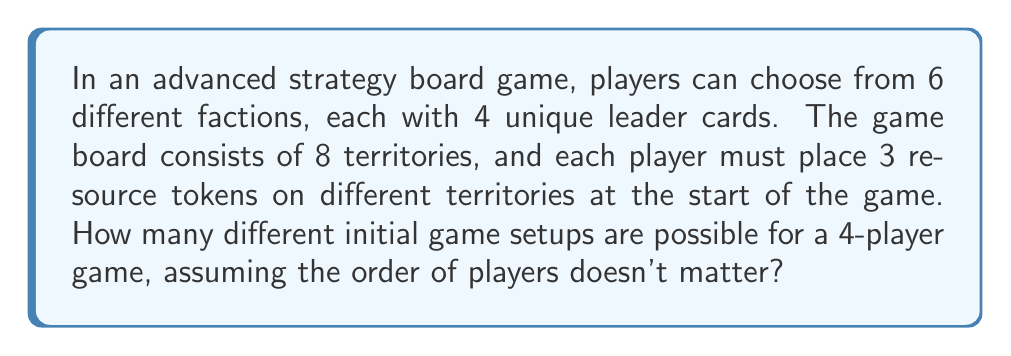Provide a solution to this math problem. Let's break this down step by step:

1) First, we need to calculate the number of ways to choose factions:
   - We're choosing 4 factions out of 6, where order doesn't matter.
   - This is a combination, represented as $\binom{6}{4}$ or $C(6,4)$.
   - $\binom{6}{4} = \frac{6!}{4!(6-4)!} = \frac{6!}{4!2!} = 15$

2) For each faction, a player must choose 1 of 4 leader cards:
   - There are 4 choices for each of the 4 players.
   - This is a multiplication: $4^4 = 256$

3) Now, for the resource placement:
   - Each player must place 3 tokens on different territories out of 8.
   - This is another combination for each player: $\binom{8}{3}$
   - $\binom{8}{3} = \frac{8!}{3!(8-3)!} = \frac{8!}{3!5!} = 56$
   - This must be done for all 4 players: $56^4$

4) By the multiplication principle, we multiply all these possibilities:
   $$ 15 \times 256 \times 56^4 $$

5) Calculate the final result:
   $$ 15 \times 256 \times 56^4 = 15 \times 256 \times 9,834,496 = 37,806,866,400 $$

Therefore, there are 37,806,866,400 different possible initial game setups.
Answer: 37,806,866,400 